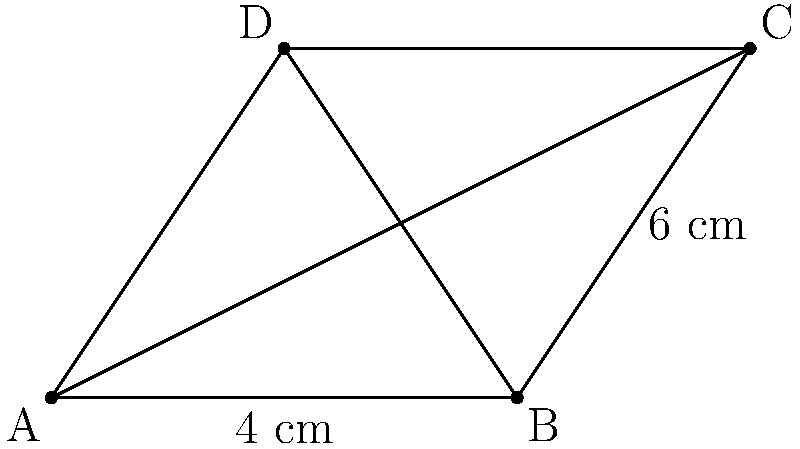You've been nominated for a prestigious film award, and the organizers have designed a unique rhombus-shaped plaque for the winners. The plaque's diagonal from corner A to C measures 6 cm, while the side length is 4 cm. As a director known for visual precision, you're curious about the length of the other diagonal (BD). What is the length of diagonal BD in centimeters? Let's approach this step-by-step:

1) In a rhombus, the diagonals bisect each other at right angles. This means we can split the rhombus into four congruent right triangles.

2) Let's focus on one of these right triangles. We know:
   - The hypotenuse (side of the rhombus) is 4 cm
   - Half of diagonal AC is 3 cm (since the full diagonal is 6 cm)

3) Let's call half of the unknown diagonal BD as x.

4) We can use the Pythagorean theorem in this right triangle:
   $$ x^2 + 3^2 = 4^2 $$

5) Simplify:
   $$ x^2 + 9 = 16 $$

6) Subtract 9 from both sides:
   $$ x^2 = 7 $$

7) Take the square root of both sides:
   $$ x = \sqrt{7} $$

8) Remember, this is only half of diagonal BD. To get the full length, we need to double this:
   $$ BD = 2\sqrt{7} \text{ cm} $$
Answer: $2\sqrt{7}$ cm 